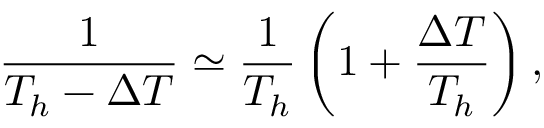Convert formula to latex. <formula><loc_0><loc_0><loc_500><loc_500>\frac { 1 } { T _ { h } - \Delta T } \simeq \frac { 1 } { T _ { h } } \left ( 1 + \frac { \Delta T } { T _ { h } } \right ) ,</formula> 